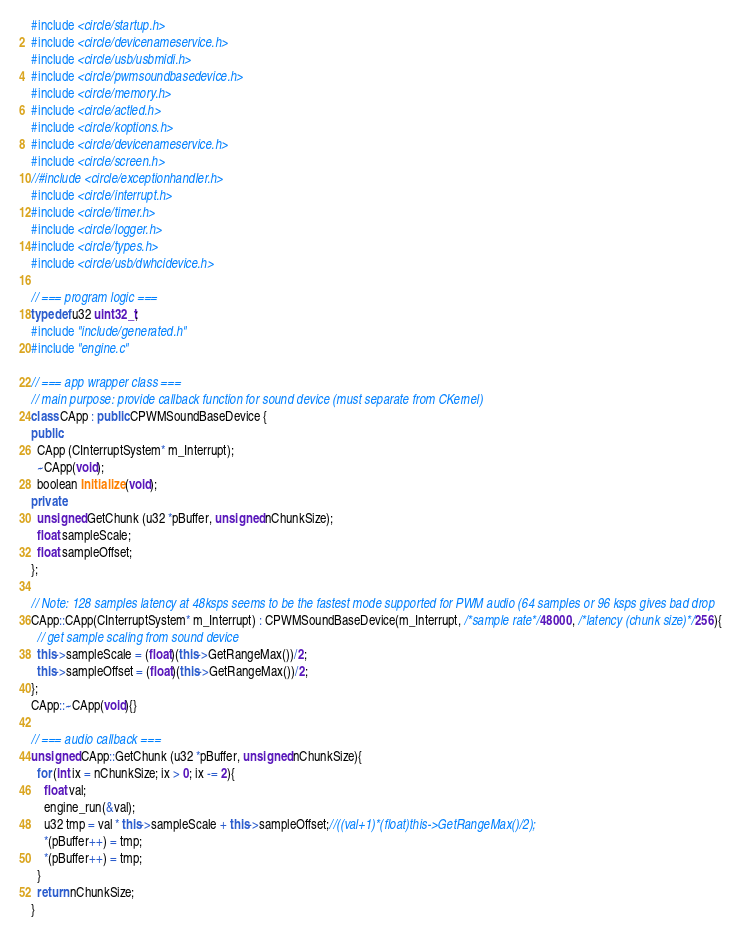<code> <loc_0><loc_0><loc_500><loc_500><_C++_>#include <circle/startup.h>
#include <circle/devicenameservice.h>
#include <circle/usb/usbmidi.h>
#include <circle/pwmsoundbasedevice.h>
#include <circle/memory.h>
#include <circle/actled.h>
#include <circle/koptions.h>
#include <circle/devicenameservice.h>
#include <circle/screen.h>
//#include <circle/exceptionhandler.h>
#include <circle/interrupt.h>
#include <circle/timer.h>
#include <circle/logger.h>
#include <circle/types.h>
#include <circle/usb/dwhcidevice.h>

// === program logic ===
typedef u32 uint32_t;
#include "include/generated.h"
#include "engine.c"

// === app wrapper class ===
// main purpose: provide callback function for sound device (must separate from CKernel)
class CApp : public CPWMSoundBaseDevice {
public:
  CApp (CInterruptSystem* m_Interrupt);
  ~CApp(void);
  boolean Initialize (void);
private:
  unsigned GetChunk (u32 *pBuffer, unsigned nChunkSize);
  float sampleScale;
  float sampleOffset;
};

// Note: 128 samples latency at 48ksps seems to be the fastest mode supported for PWM audio (64 samples or 96 ksps gives bad drop
CApp::CApp(CInterruptSystem* m_Interrupt) : CPWMSoundBaseDevice(m_Interrupt, /*sample rate*/48000, /*latency (chunk size)*/256){
  // get sample scaling from sound device
  this->sampleScale = (float)(this->GetRangeMax())/2;
  this->sampleOffset = (float)(this->GetRangeMax())/2;
};
CApp::~CApp(void){}

// === audio callback ===
unsigned CApp::GetChunk (u32 *pBuffer, unsigned nChunkSize){
  for (int ix = nChunkSize; ix > 0; ix -= 2){
    float val;
    engine_run(&val);
    u32 tmp = val * this->sampleScale + this->sampleOffset;//((val+1)*(float)this->GetRangeMax()/2);
    *(pBuffer++) = tmp;
    *(pBuffer++) = tmp;
  }
  return nChunkSize;
}</code> 